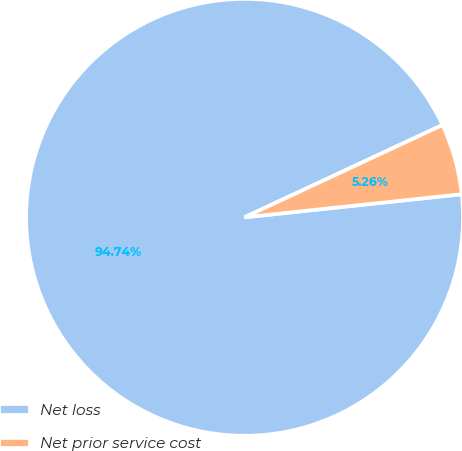<chart> <loc_0><loc_0><loc_500><loc_500><pie_chart><fcel>Net loss<fcel>Net prior service cost<nl><fcel>94.74%<fcel>5.26%<nl></chart> 